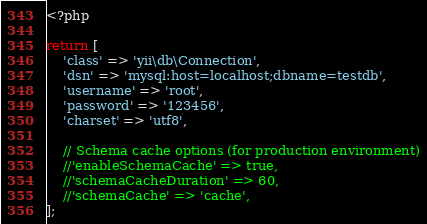Convert code to text. <code><loc_0><loc_0><loc_500><loc_500><_PHP_><?php

return [
    'class' => 'yii\db\Connection',
    'dsn' => 'mysql:host=localhost;dbname=testdb',
    'username' => 'root',
    'password' => '123456',
    'charset' => 'utf8',

    // Schema cache options (for production environment)
    //'enableSchemaCache' => true,
    //'schemaCacheDuration' => 60,
    //'schemaCache' => 'cache',
];
</code> 